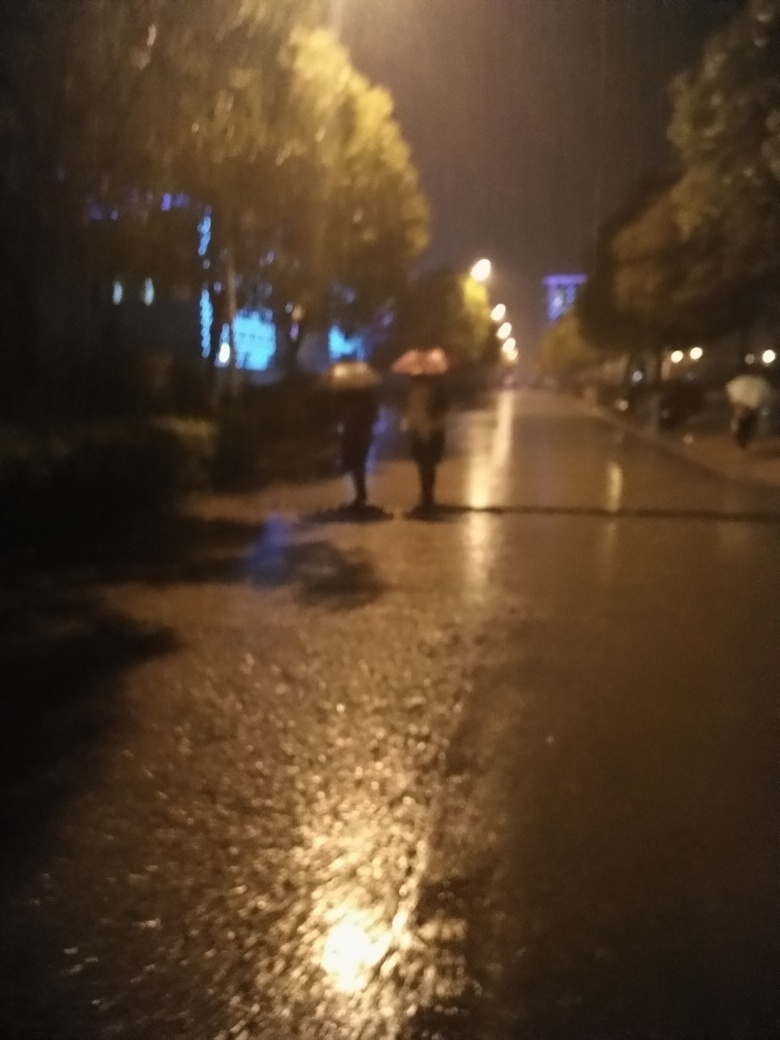Could you guess the time when this photo was likely taken? Given the image's dark ambiance and artificial lighting, it likely depicts a scene from the late evening or night time. The presence of people with umbrellas suggests that it was probably taken shortly after a rainfall when people are still out and about. 